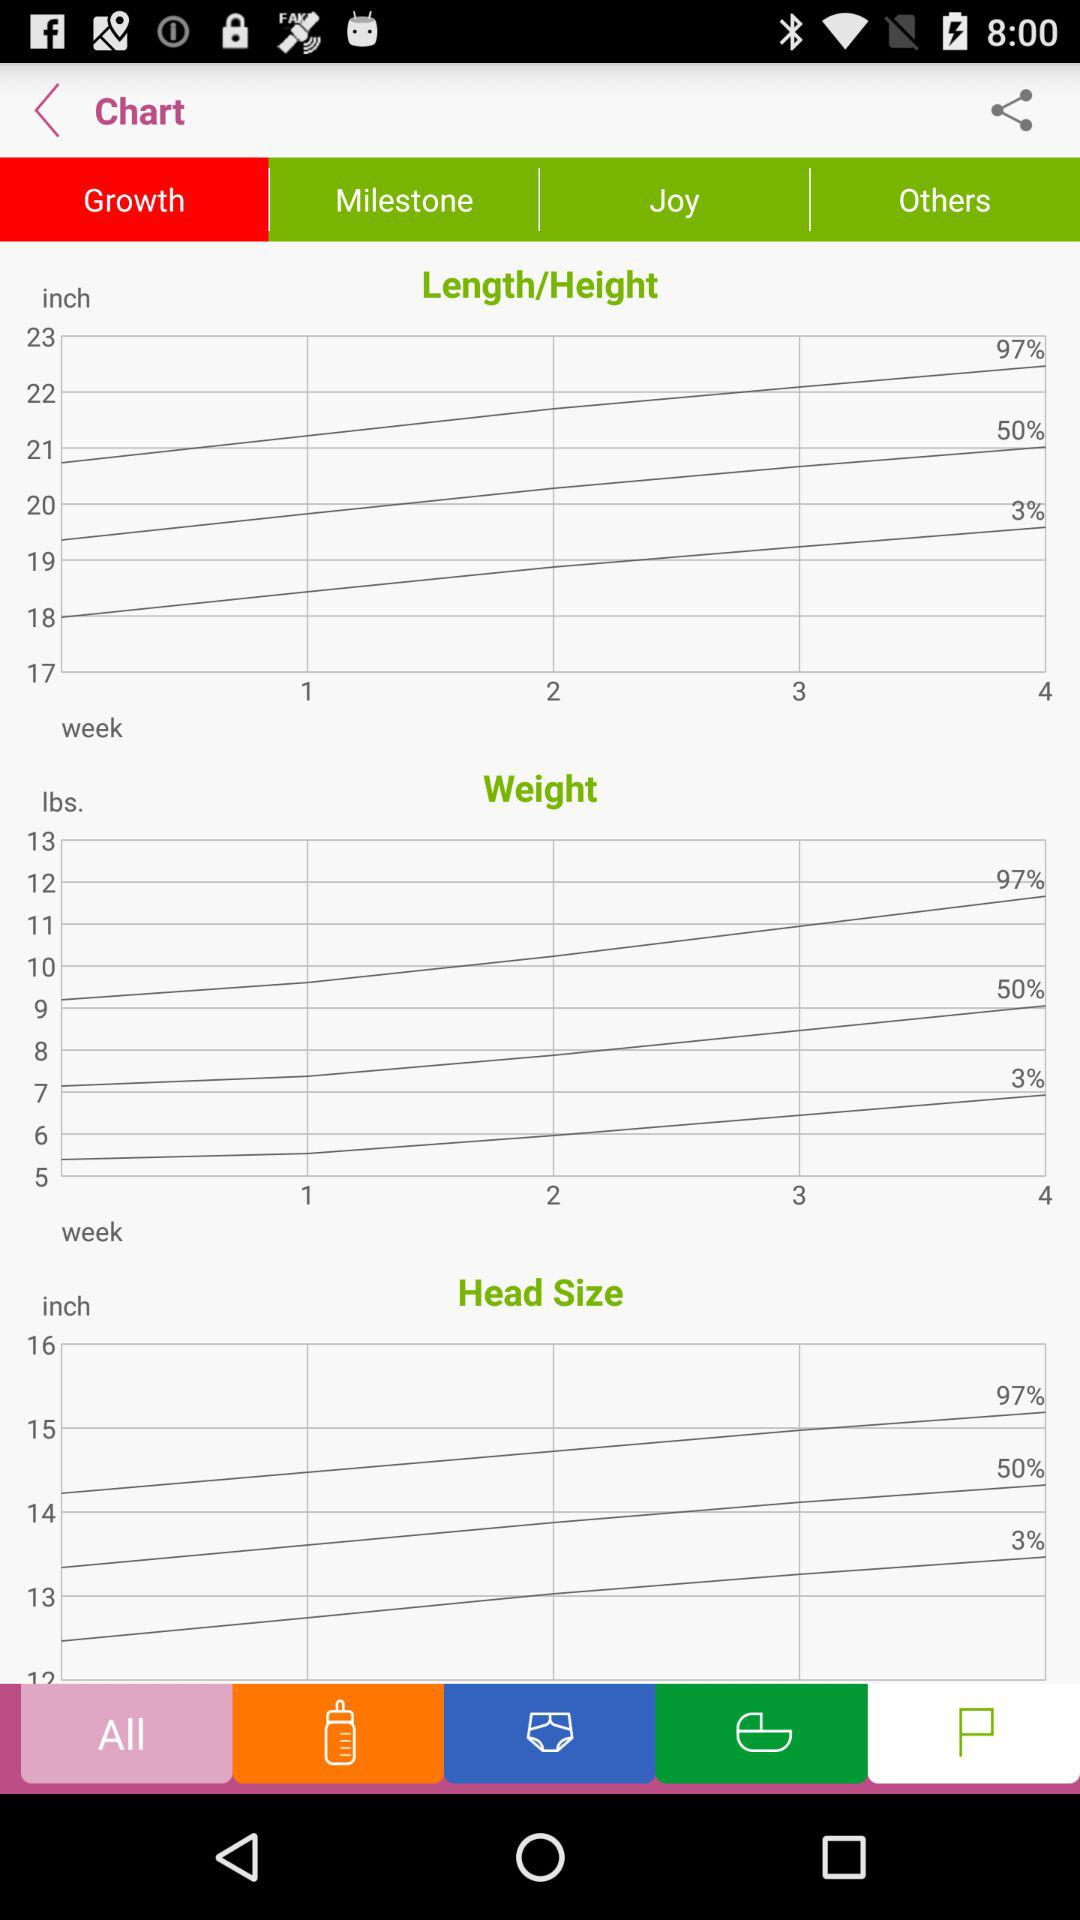Which tab has been selected? The selected tab is "Growth". 